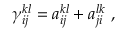<formula> <loc_0><loc_0><loc_500><loc_500>{ \gamma } _ { i j } ^ { k l } = a _ { i j } ^ { k l } + a _ { j i } ^ { l k } ,</formula> 